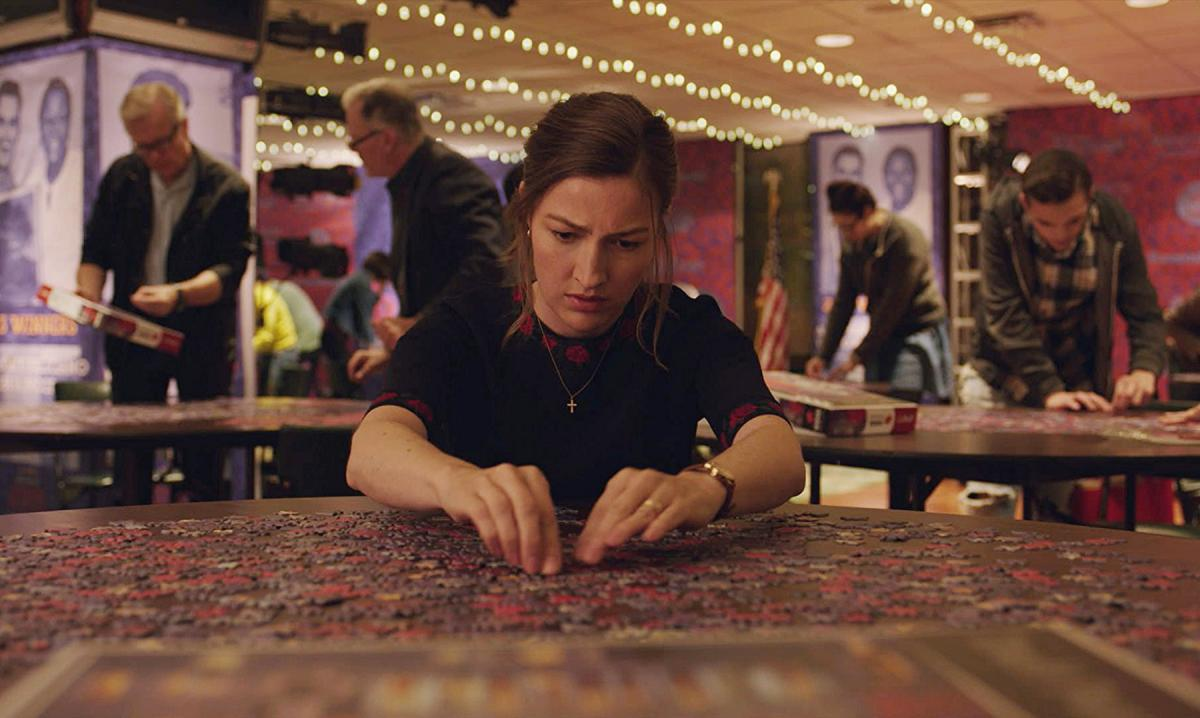What's happening in the scene?
 In this image, we see the actress Kelly Macdonald, known for her role as Agnes in the movie Puzzle. She is seated at a table, her hands resting on its surface, scattered with puzzle pieces. Her gaze is focused intently on the puzzle in front of her, suggesting deep concentration. She is dressed in a black top, and a red necklace adds a pop of color to her outfit. The setting appears to be a dimly lit room, with indistinct figures of people and posters adorning the wall in the background. The image captures a moment of quiet intensity as Agnes immerses herself in the world of puzzles. 